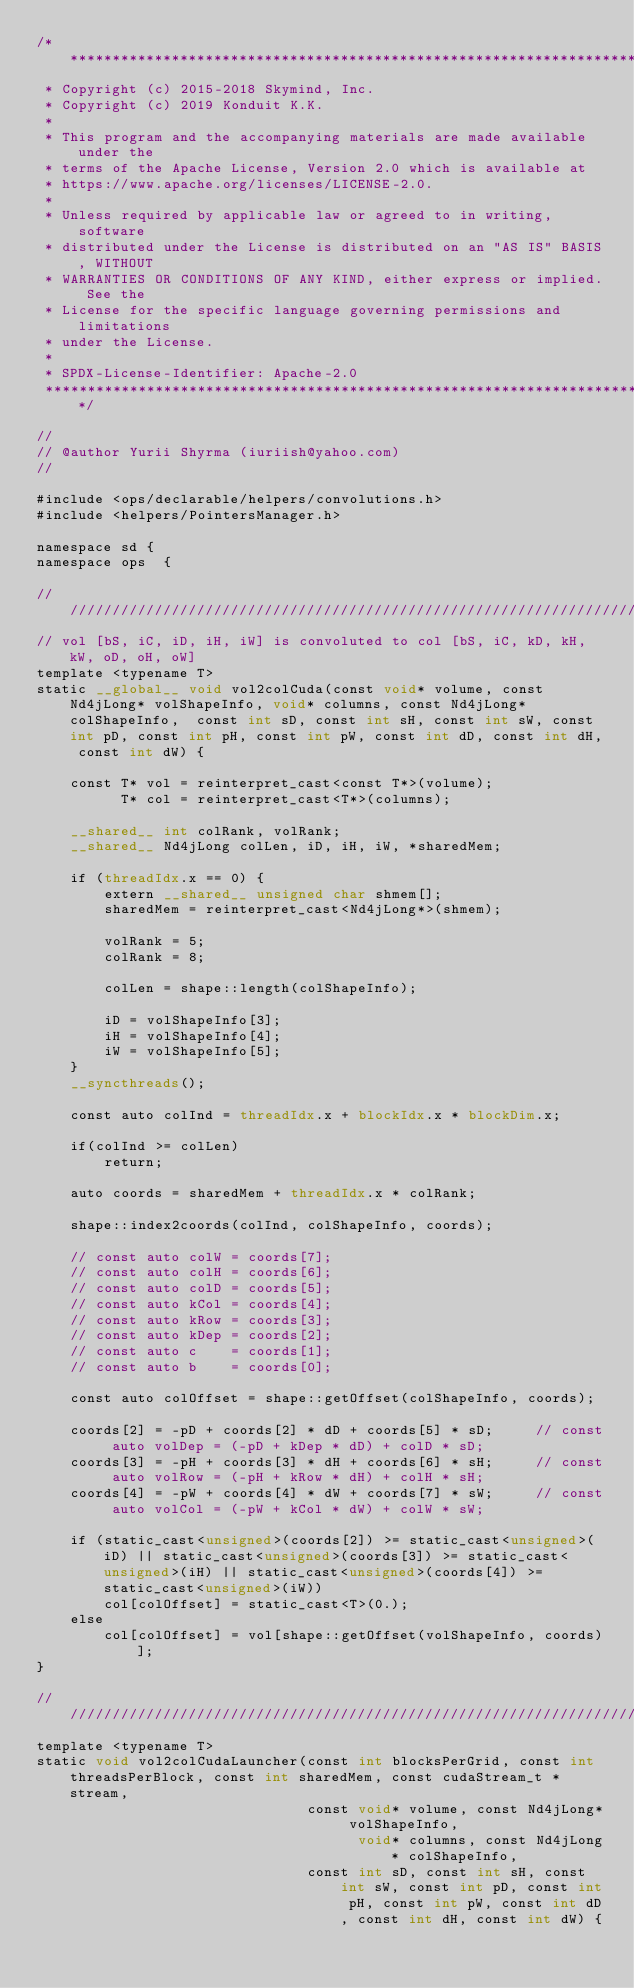Convert code to text. <code><loc_0><loc_0><loc_500><loc_500><_Cuda_>/*******************************************************************************
 * Copyright (c) 2015-2018 Skymind, Inc.
 * Copyright (c) 2019 Konduit K.K.
 *
 * This program and the accompanying materials are made available under the
 * terms of the Apache License, Version 2.0 which is available at
 * https://www.apache.org/licenses/LICENSE-2.0.
 *
 * Unless required by applicable law or agreed to in writing, software
 * distributed under the License is distributed on an "AS IS" BASIS, WITHOUT
 * WARRANTIES OR CONDITIONS OF ANY KIND, either express or implied. See the
 * License for the specific language governing permissions and limitations
 * under the License.
 *
 * SPDX-License-Identifier: Apache-2.0
 ******************************************************************************/

//
// @author Yurii Shyrma (iuriish@yahoo.com)
//

#include <ops/declarable/helpers/convolutions.h>
#include <helpers/PointersManager.h>

namespace sd {
namespace ops  {

//////////////////////////////////////////////////////////////////////////
// vol [bS, iC, iD, iH, iW] is convoluted to col [bS, iC, kD, kH, kW, oD, oH, oW]
template <typename T>
static __global__ void vol2colCuda(const void* volume, const Nd4jLong* volShapeInfo, void* columns, const Nd4jLong* colShapeInfo,  const int sD, const int sH, const int sW, const int pD, const int pH, const int pW, const int dD, const int dH, const int dW) {

    const T* vol = reinterpret_cast<const T*>(volume);
          T* col = reinterpret_cast<T*>(columns);

    __shared__ int colRank, volRank;
    __shared__ Nd4jLong colLen, iD, iH, iW, *sharedMem;

    if (threadIdx.x == 0) {
        extern __shared__ unsigned char shmem[];
        sharedMem = reinterpret_cast<Nd4jLong*>(shmem);

        volRank = 5;
        colRank = 8;

        colLen = shape::length(colShapeInfo);

        iD = volShapeInfo[3];
        iH = volShapeInfo[4];
        iW = volShapeInfo[5];
    }
    __syncthreads();

    const auto colInd = threadIdx.x + blockIdx.x * blockDim.x;

    if(colInd >= colLen)
        return;

    auto coords = sharedMem + threadIdx.x * colRank;

    shape::index2coords(colInd, colShapeInfo, coords);

    // const auto colW = coords[7];
    // const auto colH = coords[6];
    // const auto colD = coords[5];
    // const auto kCol = coords[4];
    // const auto kRow = coords[3];
    // const auto kDep = coords[2];
    // const auto c    = coords[1];
    // const auto b    = coords[0];

    const auto colOffset = shape::getOffset(colShapeInfo, coords);

    coords[2] = -pD + coords[2] * dD + coords[5] * sD;     // const auto volDep = (-pD + kDep * dD) + colD * sD;
    coords[3] = -pH + coords[3] * dH + coords[6] * sH;     // const auto volRow = (-pH + kRow * dH) + colH * sH;
    coords[4] = -pW + coords[4] * dW + coords[7] * sW;     // const auto volCol = (-pW + kCol * dW) + colW * sW;

    if (static_cast<unsigned>(coords[2]) >= static_cast<unsigned>(iD) || static_cast<unsigned>(coords[3]) >= static_cast<unsigned>(iH) || static_cast<unsigned>(coords[4]) >= static_cast<unsigned>(iW))
        col[colOffset] = static_cast<T>(0.);
    else
        col[colOffset] = vol[shape::getOffset(volShapeInfo, coords)];
}

//////////////////////////////////////////////////////////////////////////
template <typename T>
static void vol2colCudaLauncher(const int blocksPerGrid, const int threadsPerBlock, const int sharedMem, const cudaStream_t *stream,
                                const void* volume, const Nd4jLong* volShapeInfo,
                                      void* columns, const Nd4jLong* colShapeInfo,
                                const int sD, const int sH, const int sW, const int pD, const int pH, const int pW, const int dD, const int dH, const int dW) {
</code> 